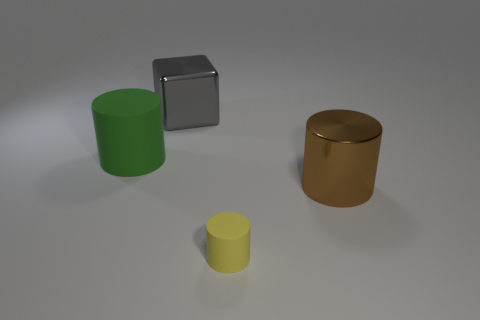Subtract all matte cylinders. How many cylinders are left? 1 Add 2 metal blocks. How many objects exist? 6 Subtract all cylinders. How many objects are left? 1 Subtract all things. Subtract all small purple spheres. How many objects are left? 0 Add 2 big gray shiny blocks. How many big gray shiny blocks are left? 3 Add 4 big things. How many big things exist? 7 Subtract 1 yellow cylinders. How many objects are left? 3 